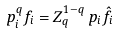<formula> <loc_0><loc_0><loc_500><loc_500>p _ { i } ^ { q } f _ { i } = Z _ { q } ^ { 1 - q } \, p _ { i } \hat { f } _ { i }</formula> 